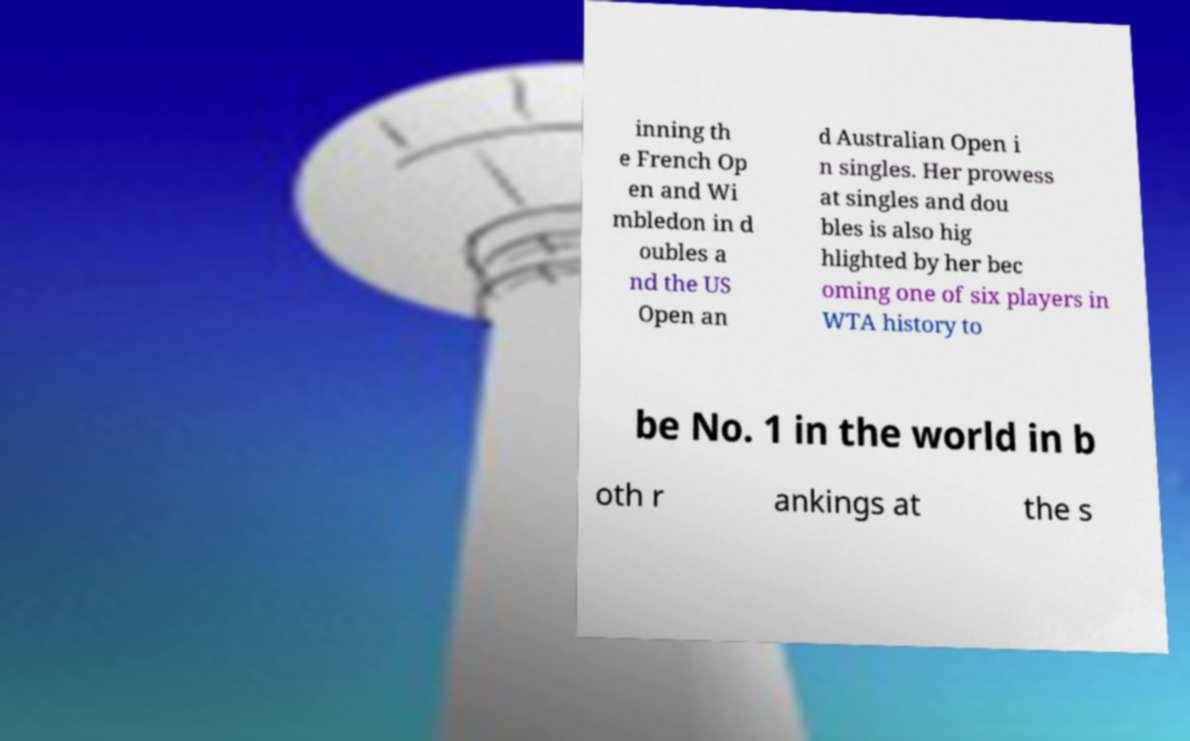What messages or text are displayed in this image? I need them in a readable, typed format. inning th e French Op en and Wi mbledon in d oubles a nd the US Open an d Australian Open i n singles. Her prowess at singles and dou bles is also hig hlighted by her bec oming one of six players in WTA history to be No. 1 in the world in b oth r ankings at the s 